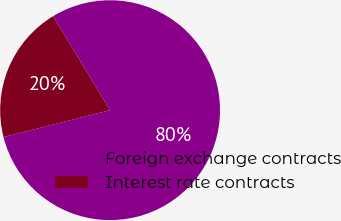Convert chart to OTSL. <chart><loc_0><loc_0><loc_500><loc_500><pie_chart><fcel>Foreign exchange contracts<fcel>Interest rate contracts<nl><fcel>79.74%<fcel>20.26%<nl></chart> 